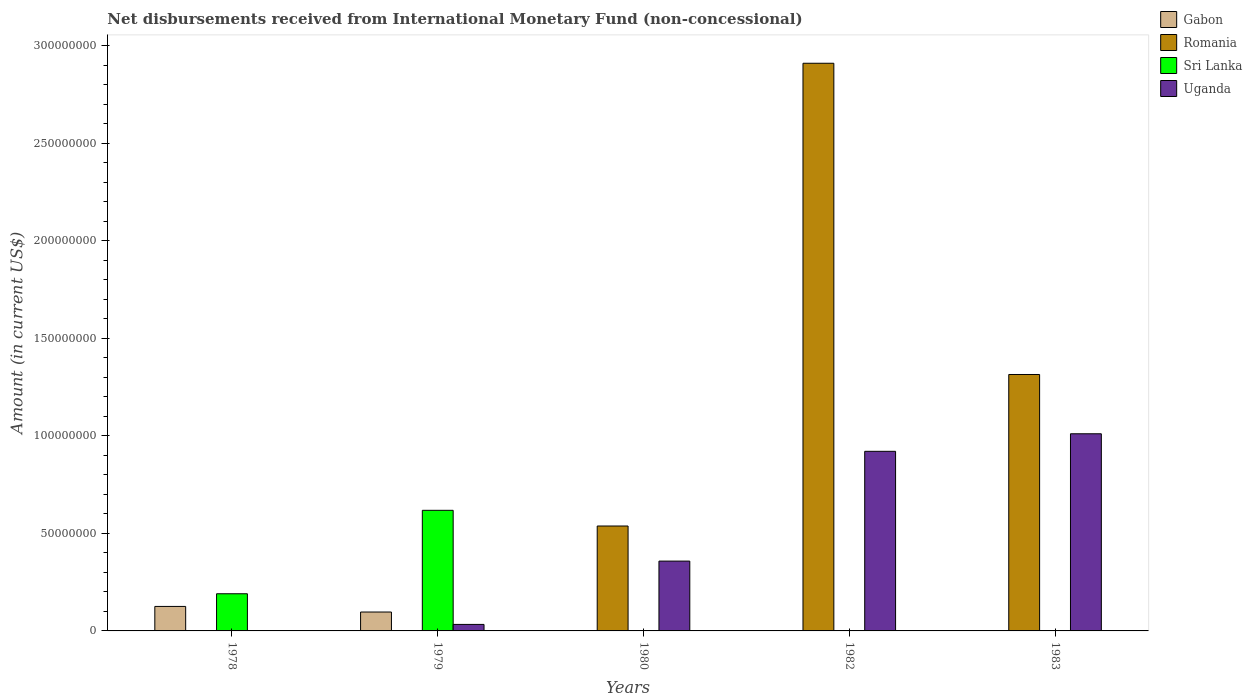How many different coloured bars are there?
Your answer should be very brief. 4. How many groups of bars are there?
Provide a short and direct response. 5. Are the number of bars on each tick of the X-axis equal?
Provide a short and direct response. No. How many bars are there on the 2nd tick from the left?
Your answer should be very brief. 3. How many bars are there on the 5th tick from the right?
Offer a terse response. 2. In how many cases, is the number of bars for a given year not equal to the number of legend labels?
Provide a short and direct response. 5. What is the amount of disbursements received from International Monetary Fund in Sri Lanka in 1983?
Offer a very short reply. 0. Across all years, what is the maximum amount of disbursements received from International Monetary Fund in Romania?
Provide a succinct answer. 2.91e+08. In which year was the amount of disbursements received from International Monetary Fund in Uganda maximum?
Your answer should be very brief. 1983. What is the total amount of disbursements received from International Monetary Fund in Sri Lanka in the graph?
Offer a terse response. 8.09e+07. What is the difference between the amount of disbursements received from International Monetary Fund in Uganda in 1979 and that in 1980?
Provide a succinct answer. -3.25e+07. What is the difference between the amount of disbursements received from International Monetary Fund in Uganda in 1980 and the amount of disbursements received from International Monetary Fund in Romania in 1979?
Make the answer very short. 3.58e+07. What is the average amount of disbursements received from International Monetary Fund in Uganda per year?
Offer a terse response. 4.65e+07. In the year 1978, what is the difference between the amount of disbursements received from International Monetary Fund in Sri Lanka and amount of disbursements received from International Monetary Fund in Gabon?
Offer a terse response. 6.50e+06. In how many years, is the amount of disbursements received from International Monetary Fund in Romania greater than 120000000 US$?
Ensure brevity in your answer.  2. What is the difference between the highest and the second highest amount of disbursements received from International Monetary Fund in Romania?
Your answer should be very brief. 1.60e+08. What is the difference between the highest and the lowest amount of disbursements received from International Monetary Fund in Uganda?
Make the answer very short. 1.01e+08. Are all the bars in the graph horizontal?
Keep it short and to the point. No. What is the difference between two consecutive major ticks on the Y-axis?
Your answer should be compact. 5.00e+07. Does the graph contain grids?
Make the answer very short. No. Where does the legend appear in the graph?
Provide a succinct answer. Top right. How many legend labels are there?
Your answer should be very brief. 4. What is the title of the graph?
Make the answer very short. Net disbursements received from International Monetary Fund (non-concessional). What is the label or title of the X-axis?
Make the answer very short. Years. What is the Amount (in current US$) in Gabon in 1978?
Ensure brevity in your answer.  1.26e+07. What is the Amount (in current US$) of Sri Lanka in 1978?
Offer a very short reply. 1.91e+07. What is the Amount (in current US$) in Gabon in 1979?
Your answer should be compact. 9.69e+06. What is the Amount (in current US$) in Sri Lanka in 1979?
Ensure brevity in your answer.  6.18e+07. What is the Amount (in current US$) in Uganda in 1979?
Provide a succinct answer. 3.33e+06. What is the Amount (in current US$) in Gabon in 1980?
Your answer should be very brief. 0. What is the Amount (in current US$) in Romania in 1980?
Keep it short and to the point. 5.38e+07. What is the Amount (in current US$) of Uganda in 1980?
Give a very brief answer. 3.58e+07. What is the Amount (in current US$) of Gabon in 1982?
Provide a succinct answer. 0. What is the Amount (in current US$) in Romania in 1982?
Offer a very short reply. 2.91e+08. What is the Amount (in current US$) in Sri Lanka in 1982?
Make the answer very short. 0. What is the Amount (in current US$) in Uganda in 1982?
Your answer should be compact. 9.21e+07. What is the Amount (in current US$) in Gabon in 1983?
Keep it short and to the point. 0. What is the Amount (in current US$) of Romania in 1983?
Provide a succinct answer. 1.32e+08. What is the Amount (in current US$) of Sri Lanka in 1983?
Offer a very short reply. 0. What is the Amount (in current US$) in Uganda in 1983?
Your response must be concise. 1.01e+08. Across all years, what is the maximum Amount (in current US$) of Gabon?
Your response must be concise. 1.26e+07. Across all years, what is the maximum Amount (in current US$) of Romania?
Provide a succinct answer. 2.91e+08. Across all years, what is the maximum Amount (in current US$) in Sri Lanka?
Keep it short and to the point. 6.18e+07. Across all years, what is the maximum Amount (in current US$) in Uganda?
Your response must be concise. 1.01e+08. Across all years, what is the minimum Amount (in current US$) in Gabon?
Keep it short and to the point. 0. Across all years, what is the minimum Amount (in current US$) of Sri Lanka?
Give a very brief answer. 0. What is the total Amount (in current US$) of Gabon in the graph?
Your answer should be very brief. 2.23e+07. What is the total Amount (in current US$) in Romania in the graph?
Provide a short and direct response. 4.76e+08. What is the total Amount (in current US$) in Sri Lanka in the graph?
Provide a succinct answer. 8.09e+07. What is the total Amount (in current US$) in Uganda in the graph?
Ensure brevity in your answer.  2.32e+08. What is the difference between the Amount (in current US$) of Gabon in 1978 and that in 1979?
Your response must be concise. 2.87e+06. What is the difference between the Amount (in current US$) of Sri Lanka in 1978 and that in 1979?
Keep it short and to the point. -4.28e+07. What is the difference between the Amount (in current US$) in Uganda in 1979 and that in 1980?
Your answer should be compact. -3.25e+07. What is the difference between the Amount (in current US$) in Uganda in 1979 and that in 1982?
Provide a short and direct response. -8.88e+07. What is the difference between the Amount (in current US$) of Uganda in 1979 and that in 1983?
Provide a short and direct response. -9.78e+07. What is the difference between the Amount (in current US$) in Romania in 1980 and that in 1982?
Offer a very short reply. -2.37e+08. What is the difference between the Amount (in current US$) of Uganda in 1980 and that in 1982?
Provide a succinct answer. -5.63e+07. What is the difference between the Amount (in current US$) of Romania in 1980 and that in 1983?
Ensure brevity in your answer.  -7.77e+07. What is the difference between the Amount (in current US$) in Uganda in 1980 and that in 1983?
Provide a succinct answer. -6.53e+07. What is the difference between the Amount (in current US$) in Romania in 1982 and that in 1983?
Your answer should be compact. 1.60e+08. What is the difference between the Amount (in current US$) in Uganda in 1982 and that in 1983?
Your response must be concise. -9.00e+06. What is the difference between the Amount (in current US$) in Gabon in 1978 and the Amount (in current US$) in Sri Lanka in 1979?
Give a very brief answer. -4.93e+07. What is the difference between the Amount (in current US$) in Gabon in 1978 and the Amount (in current US$) in Uganda in 1979?
Ensure brevity in your answer.  9.23e+06. What is the difference between the Amount (in current US$) in Sri Lanka in 1978 and the Amount (in current US$) in Uganda in 1979?
Provide a short and direct response. 1.57e+07. What is the difference between the Amount (in current US$) of Gabon in 1978 and the Amount (in current US$) of Romania in 1980?
Your response must be concise. -4.12e+07. What is the difference between the Amount (in current US$) of Gabon in 1978 and the Amount (in current US$) of Uganda in 1980?
Offer a terse response. -2.32e+07. What is the difference between the Amount (in current US$) of Sri Lanka in 1978 and the Amount (in current US$) of Uganda in 1980?
Provide a succinct answer. -1.67e+07. What is the difference between the Amount (in current US$) of Gabon in 1978 and the Amount (in current US$) of Romania in 1982?
Make the answer very short. -2.79e+08. What is the difference between the Amount (in current US$) of Gabon in 1978 and the Amount (in current US$) of Uganda in 1982?
Your answer should be compact. -7.95e+07. What is the difference between the Amount (in current US$) in Sri Lanka in 1978 and the Amount (in current US$) in Uganda in 1982?
Your answer should be compact. -7.30e+07. What is the difference between the Amount (in current US$) of Gabon in 1978 and the Amount (in current US$) of Romania in 1983?
Ensure brevity in your answer.  -1.19e+08. What is the difference between the Amount (in current US$) in Gabon in 1978 and the Amount (in current US$) in Uganda in 1983?
Your response must be concise. -8.85e+07. What is the difference between the Amount (in current US$) of Sri Lanka in 1978 and the Amount (in current US$) of Uganda in 1983?
Provide a short and direct response. -8.20e+07. What is the difference between the Amount (in current US$) in Gabon in 1979 and the Amount (in current US$) in Romania in 1980?
Your answer should be compact. -4.41e+07. What is the difference between the Amount (in current US$) in Gabon in 1979 and the Amount (in current US$) in Uganda in 1980?
Offer a terse response. -2.61e+07. What is the difference between the Amount (in current US$) of Sri Lanka in 1979 and the Amount (in current US$) of Uganda in 1980?
Your response must be concise. 2.60e+07. What is the difference between the Amount (in current US$) in Gabon in 1979 and the Amount (in current US$) in Romania in 1982?
Offer a terse response. -2.81e+08. What is the difference between the Amount (in current US$) of Gabon in 1979 and the Amount (in current US$) of Uganda in 1982?
Offer a very short reply. -8.24e+07. What is the difference between the Amount (in current US$) of Sri Lanka in 1979 and the Amount (in current US$) of Uganda in 1982?
Keep it short and to the point. -3.03e+07. What is the difference between the Amount (in current US$) of Gabon in 1979 and the Amount (in current US$) of Romania in 1983?
Offer a very short reply. -1.22e+08. What is the difference between the Amount (in current US$) in Gabon in 1979 and the Amount (in current US$) in Uganda in 1983?
Offer a very short reply. -9.14e+07. What is the difference between the Amount (in current US$) in Sri Lanka in 1979 and the Amount (in current US$) in Uganda in 1983?
Keep it short and to the point. -3.93e+07. What is the difference between the Amount (in current US$) in Romania in 1980 and the Amount (in current US$) in Uganda in 1982?
Offer a terse response. -3.83e+07. What is the difference between the Amount (in current US$) of Romania in 1980 and the Amount (in current US$) of Uganda in 1983?
Give a very brief answer. -4.73e+07. What is the difference between the Amount (in current US$) in Romania in 1982 and the Amount (in current US$) in Uganda in 1983?
Give a very brief answer. 1.90e+08. What is the average Amount (in current US$) in Gabon per year?
Ensure brevity in your answer.  4.45e+06. What is the average Amount (in current US$) in Romania per year?
Your answer should be compact. 9.53e+07. What is the average Amount (in current US$) in Sri Lanka per year?
Provide a short and direct response. 1.62e+07. What is the average Amount (in current US$) of Uganda per year?
Provide a short and direct response. 4.65e+07. In the year 1978, what is the difference between the Amount (in current US$) in Gabon and Amount (in current US$) in Sri Lanka?
Offer a terse response. -6.50e+06. In the year 1979, what is the difference between the Amount (in current US$) in Gabon and Amount (in current US$) in Sri Lanka?
Keep it short and to the point. -5.22e+07. In the year 1979, what is the difference between the Amount (in current US$) of Gabon and Amount (in current US$) of Uganda?
Offer a very short reply. 6.36e+06. In the year 1979, what is the difference between the Amount (in current US$) in Sri Lanka and Amount (in current US$) in Uganda?
Your answer should be very brief. 5.85e+07. In the year 1980, what is the difference between the Amount (in current US$) of Romania and Amount (in current US$) of Uganda?
Offer a terse response. 1.80e+07. In the year 1982, what is the difference between the Amount (in current US$) in Romania and Amount (in current US$) in Uganda?
Provide a succinct answer. 1.99e+08. In the year 1983, what is the difference between the Amount (in current US$) in Romania and Amount (in current US$) in Uganda?
Provide a succinct answer. 3.04e+07. What is the ratio of the Amount (in current US$) of Gabon in 1978 to that in 1979?
Ensure brevity in your answer.  1.3. What is the ratio of the Amount (in current US$) in Sri Lanka in 1978 to that in 1979?
Keep it short and to the point. 0.31. What is the ratio of the Amount (in current US$) in Uganda in 1979 to that in 1980?
Your response must be concise. 0.09. What is the ratio of the Amount (in current US$) in Uganda in 1979 to that in 1982?
Make the answer very short. 0.04. What is the ratio of the Amount (in current US$) of Uganda in 1979 to that in 1983?
Offer a terse response. 0.03. What is the ratio of the Amount (in current US$) of Romania in 1980 to that in 1982?
Offer a very short reply. 0.18. What is the ratio of the Amount (in current US$) in Uganda in 1980 to that in 1982?
Offer a terse response. 0.39. What is the ratio of the Amount (in current US$) of Romania in 1980 to that in 1983?
Offer a terse response. 0.41. What is the ratio of the Amount (in current US$) of Uganda in 1980 to that in 1983?
Give a very brief answer. 0.35. What is the ratio of the Amount (in current US$) in Romania in 1982 to that in 1983?
Your response must be concise. 2.21. What is the ratio of the Amount (in current US$) of Uganda in 1982 to that in 1983?
Keep it short and to the point. 0.91. What is the difference between the highest and the second highest Amount (in current US$) of Romania?
Your answer should be compact. 1.60e+08. What is the difference between the highest and the second highest Amount (in current US$) in Uganda?
Offer a very short reply. 9.00e+06. What is the difference between the highest and the lowest Amount (in current US$) in Gabon?
Your answer should be very brief. 1.26e+07. What is the difference between the highest and the lowest Amount (in current US$) of Romania?
Your answer should be very brief. 2.91e+08. What is the difference between the highest and the lowest Amount (in current US$) in Sri Lanka?
Your answer should be compact. 6.18e+07. What is the difference between the highest and the lowest Amount (in current US$) of Uganda?
Keep it short and to the point. 1.01e+08. 